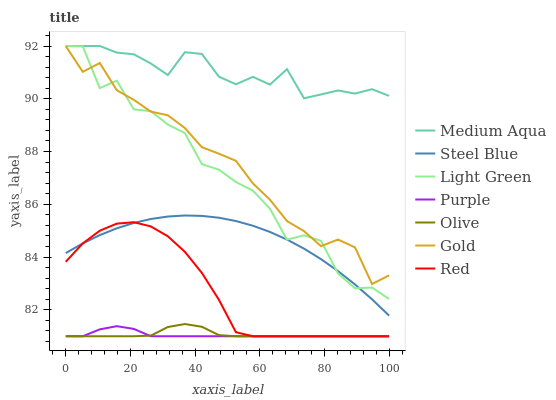Does Purple have the minimum area under the curve?
Answer yes or no. Yes. Does Medium Aqua have the maximum area under the curve?
Answer yes or no. Yes. Does Steel Blue have the minimum area under the curve?
Answer yes or no. No. Does Steel Blue have the maximum area under the curve?
Answer yes or no. No. Is Steel Blue the smoothest?
Answer yes or no. Yes. Is Light Green the roughest?
Answer yes or no. Yes. Is Purple the smoothest?
Answer yes or no. No. Is Purple the roughest?
Answer yes or no. No. Does Steel Blue have the lowest value?
Answer yes or no. No. Does Steel Blue have the highest value?
Answer yes or no. No. Is Olive less than Medium Aqua?
Answer yes or no. Yes. Is Light Green greater than Olive?
Answer yes or no. Yes. Does Olive intersect Medium Aqua?
Answer yes or no. No. 